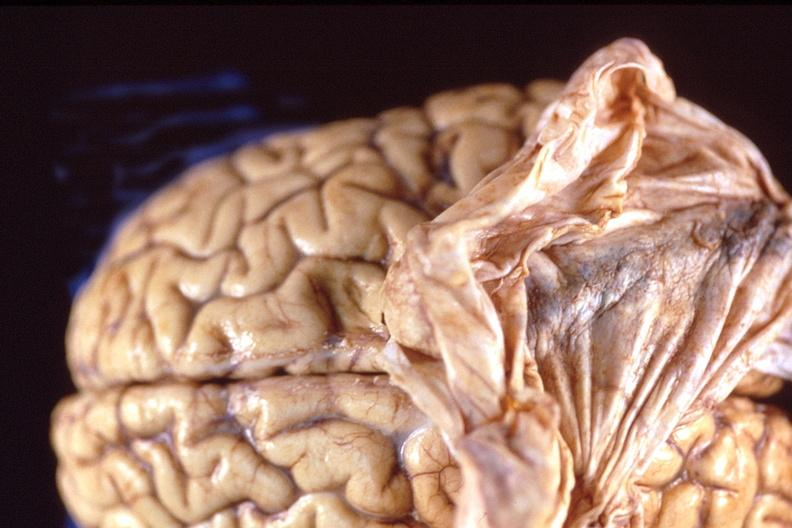does fetus developing very early show brain, breast cancer metastasis to meninges?
Answer the question using a single word or phrase. No 